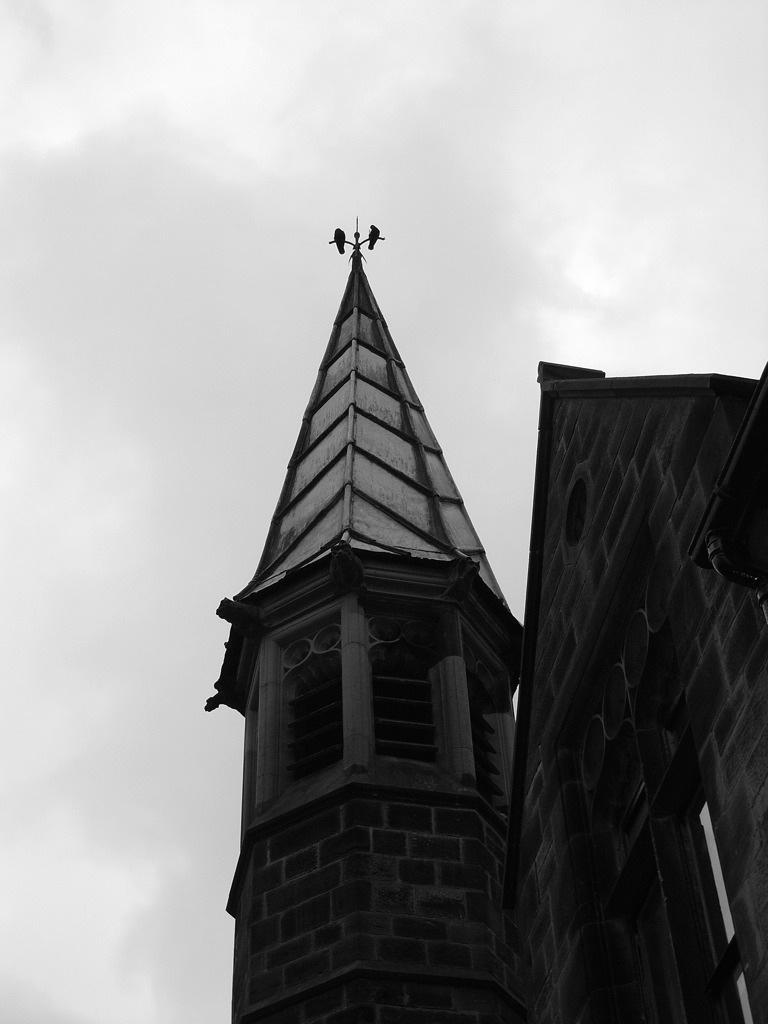How would you summarize this image in a sentence or two? This image consists of a building, windows, door and the sky. This image is taken may be in the evening. 